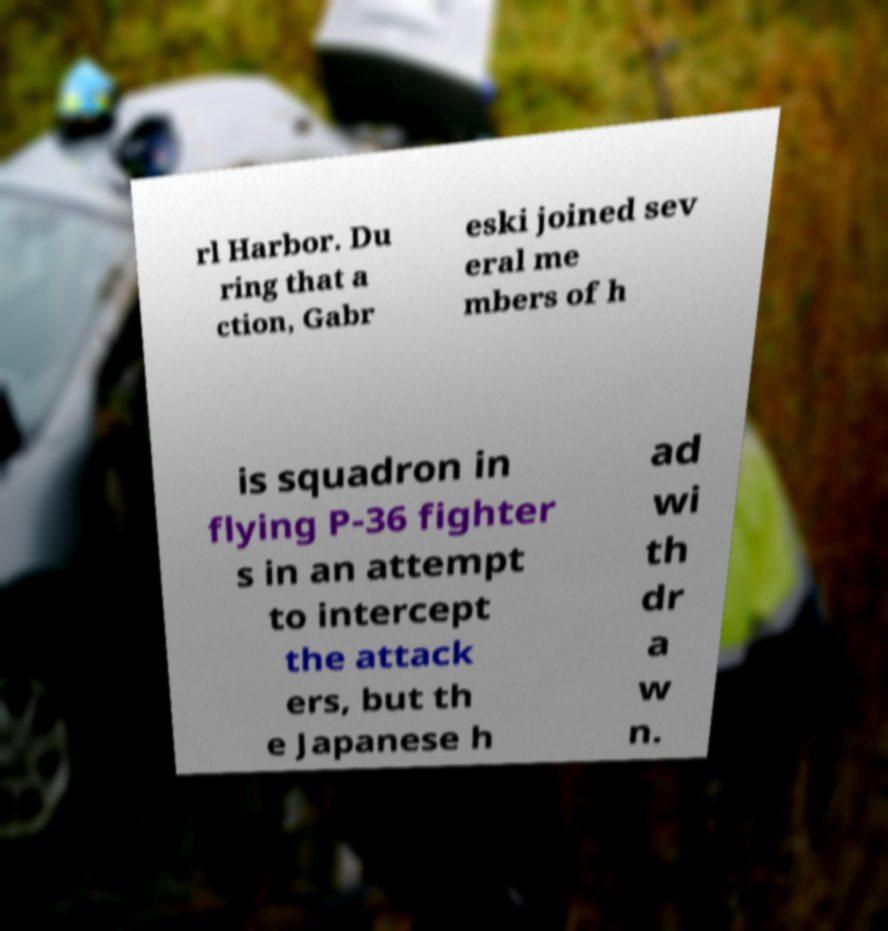Please identify and transcribe the text found in this image. rl Harbor. Du ring that a ction, Gabr eski joined sev eral me mbers of h is squadron in flying P-36 fighter s in an attempt to intercept the attack ers, but th e Japanese h ad wi th dr a w n. 